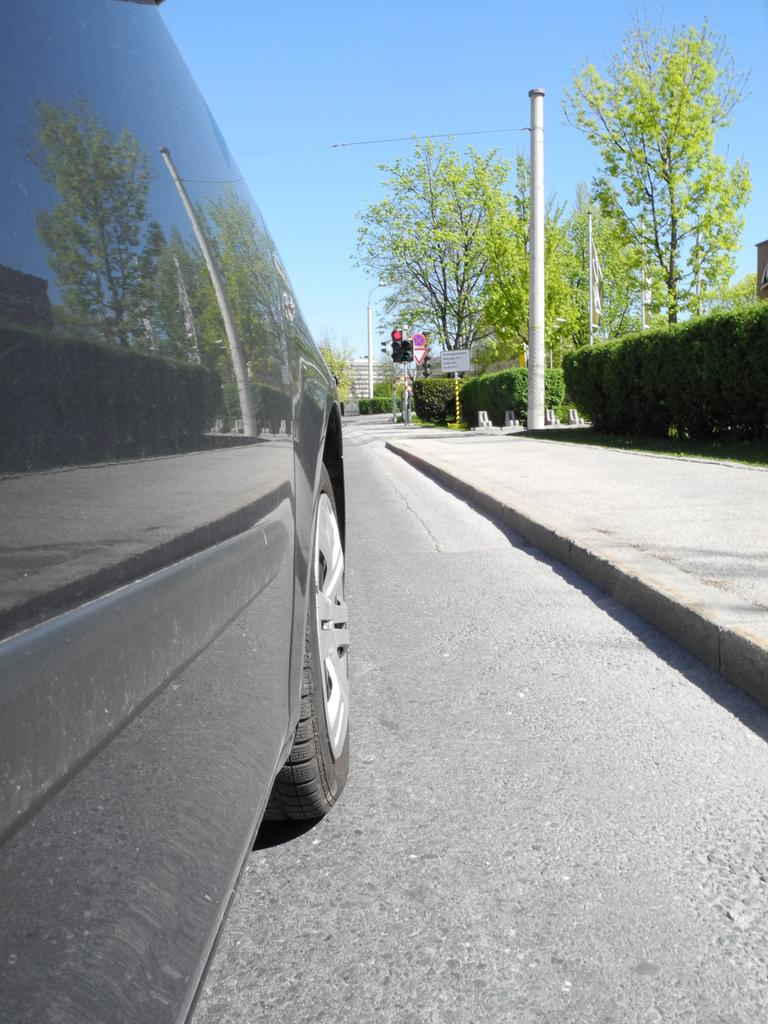What is on the road in the image? There is a vehicle on the road in the image. What can be seen directing traffic in the image? There is a traffic signal in the image. What is on the pole in the image? There are boards on a pole in the image. What is visible in the background of the image? There are trees and a building in the background of the image. What type of wax can be seen melting on the vehicle in the image? There is no wax present in the image, and therefore no wax can be seen melting on the vehicle. 